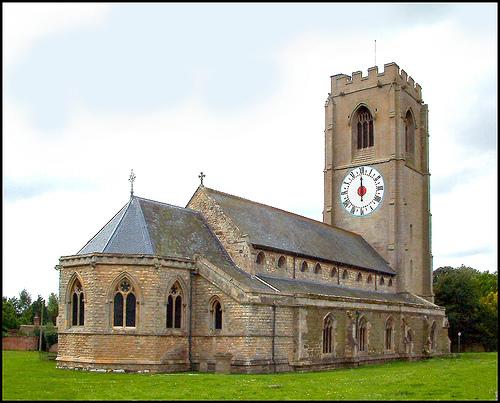What is on the tall building?
Quick response, please. Clock. Is the church old or new?
Be succinct. Old. What time does the clock say?
Quick response, please. 6:00. Is it night time?
Be succinct. No. 